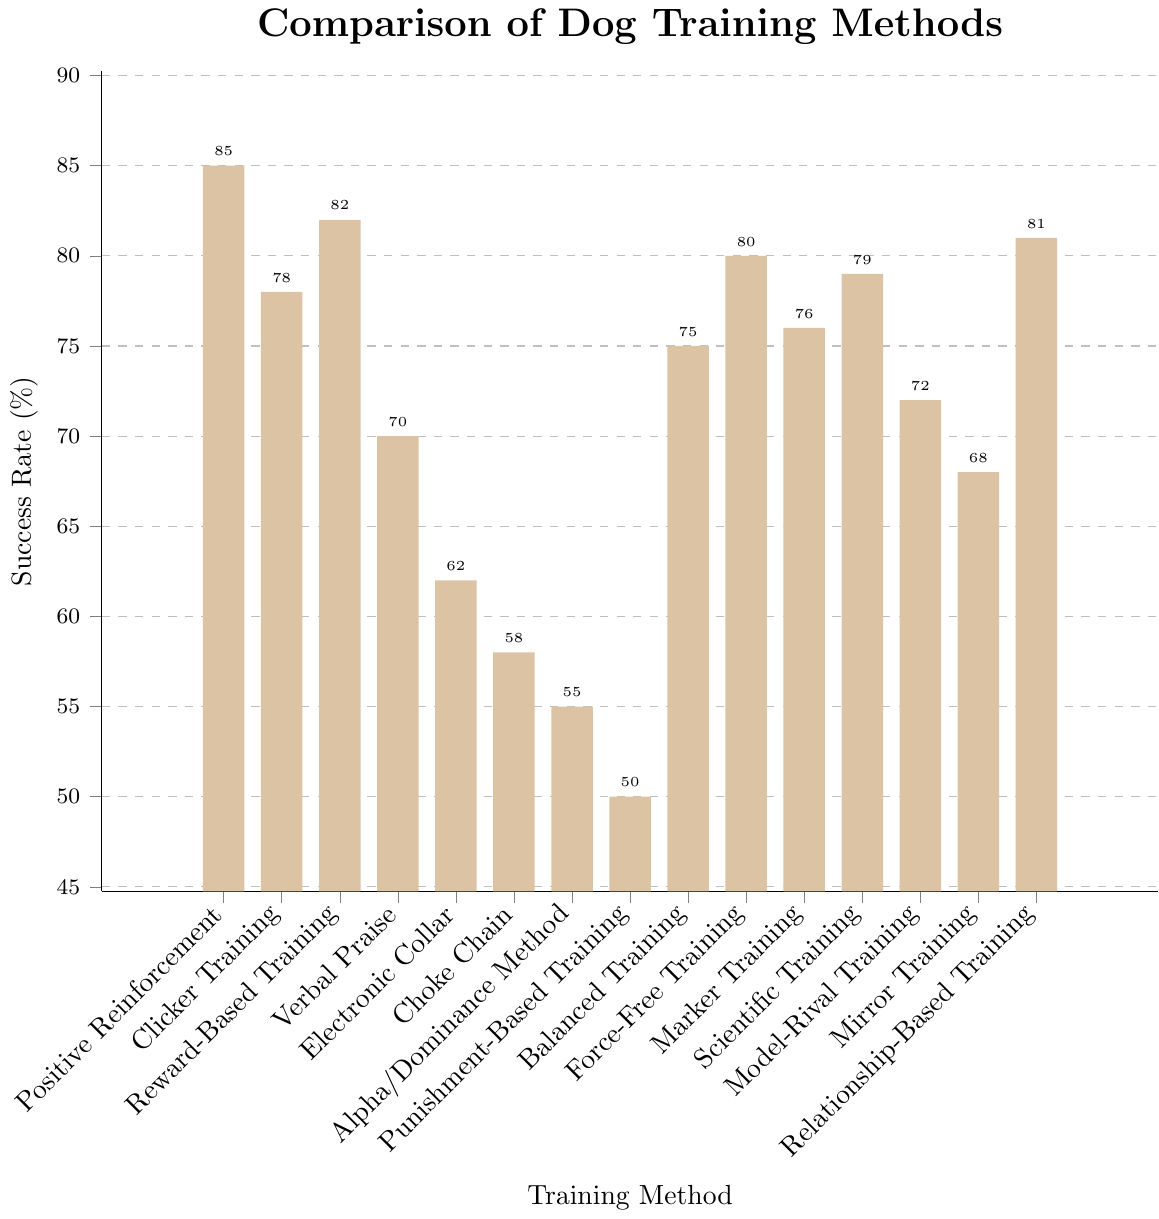Which training method has the highest success rate? By observing the heights of the bars, Positive Reinforcement has the highest value at 85%.
Answer: Positive Reinforcement Which training method has the lowest success rate? By looking at the heights of the bars, Punishment-Based Training has the lowest value at 50%.
Answer: Punishment-Based Training How much higher is the success rate of Positive Reinforcement compared to the Alpha/Dominance Method? The success rate for Positive Reinforcement is 85%, and for Alpha/Dominance Method, it is 55%. The difference is 85% - 55% = 30%.
Answer: 30% What is the average success rate of Reward-Based Training, Force-Free Training, and Relationship-Based Training? The success rates are 82%, 80%, and 81%, respectively. Sum these up: 82 + 80 + 81 = 243. The average is 243 / 3 = 81%.
Answer: 81% Which training methods have a success rate greater than 75%? The bars for Positive Reinforcement (85%), Reward-Based Training (82%), Relationship-Based Training (81%), Force-Free Training (80%), Scientific Training (79%), Marker Training (76%), and Clicker Training (78%) are all above 75%.
Answer: Positive Reinforcement, Reward-Based Training, Relationship-Based Training, Force-Free Training, Scientific Training, Marker Training, Clicker Training What is the combined success rate for Clicker Training and Scientific Training? The success rates for Clicker Training and Scientific Training are 78% and 79%, respectively. Combined, they sum up to 78% + 79% = 157%.
Answer: 157% Which training methods have a success rate less than 60%? The bars for Electronic Collar (62%), Choke Chain (58%), Alpha/Dominance Method (55%), and Punishment-Based Training (50%) are below 60%.
Answer: Choke Chain, Alpha/Dominance Method, Punishment-Based Training By how much does Verbal Praise lag behind Reward-Based Training in success rate? The success rate for Verbal Praise is 70%, and for Reward-Based Training, it is 82%. The difference is 82% - 70% = 12%.
Answer: 12% What is the total success rate for all training methods combined? Sum all success rates: 85 + 78 + 82 + 70 + 62 + 58 + 55 + 50 + 75 + 80 + 76 + 79 + 72 + 68 + 81 = 1071%.
Answer: 1071% What is the median success rate of all the training methods? Order the success rates and find the middle value:
50, 55, 58, 62, 68, 70, 72, 75, 76, 78, 79, 80, 81, 82, 85. The middle value (8th in the ordered list) is 75%.
Answer: 75% 